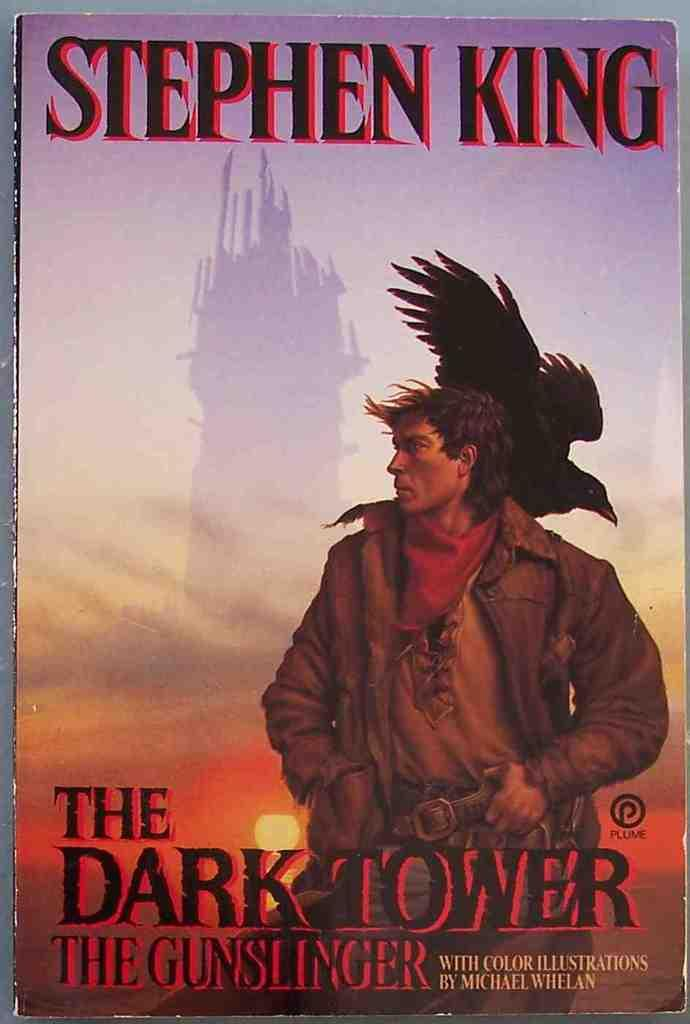<image>
Create a compact narrative representing the image presented. The Gunslinger carrying a hawk on his back stands in front of the Dark Tower. 